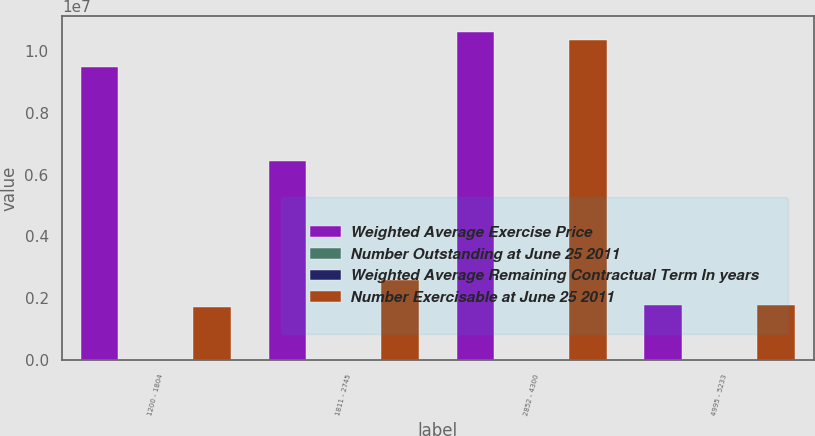<chart> <loc_0><loc_0><loc_500><loc_500><stacked_bar_chart><ecel><fcel>1200 - 1804<fcel>1811 - 2745<fcel>2852 - 4300<fcel>4995 - 5233<nl><fcel>Weighted Average Exercise Price<fcel>9.49699e+06<fcel>6.42886e+06<fcel>1.06149e+07<fcel>1.79173e+06<nl><fcel>Number Outstanding at June 25 2011<fcel>5.03<fcel>4.19<fcel>2.52<fcel>1.93<nl><fcel>Weighted Average Remaining Contractual Term In years<fcel>14.1<fcel>20.49<fcel>35.57<fcel>46.12<nl><fcel>Number Exercisable at June 25 2011<fcel>1.73133e+06<fcel>2.60308e+06<fcel>1.03572e+07<fcel>1.77697e+06<nl></chart> 